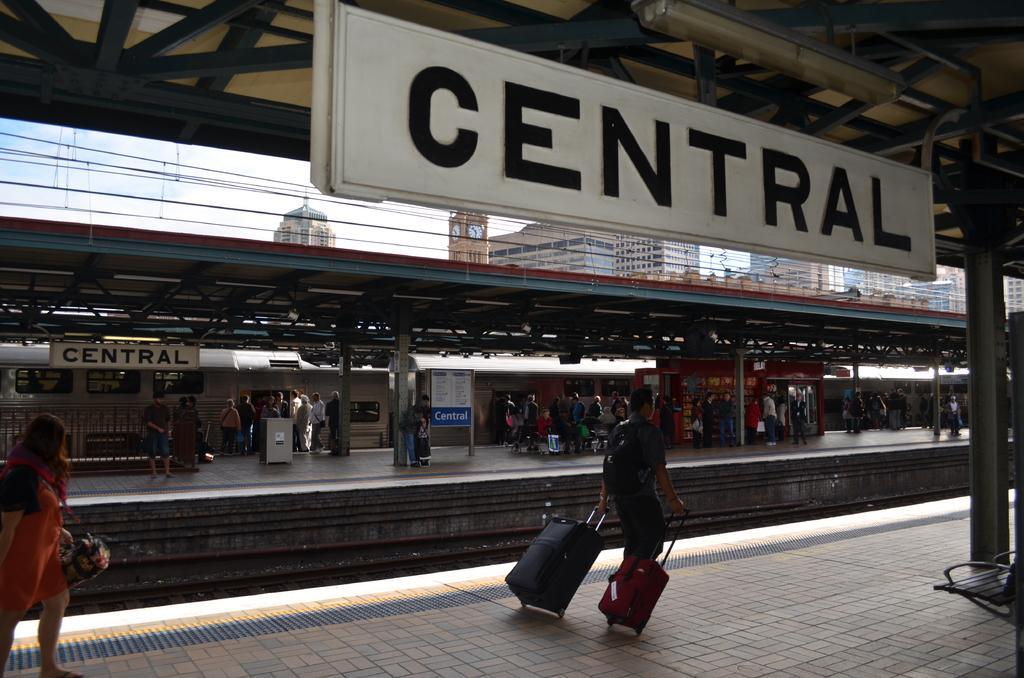Can you describe this image briefly? On the left side, there is a woman holding a bag and walking on a platform. On the right side, there is a woman, holding handles of two wheel bags and walking on the platform. Above him, there is a board attached to a roof. In the background, there are other persons on another platform, there are electric lines, buildings and there are clouds in the sky. 